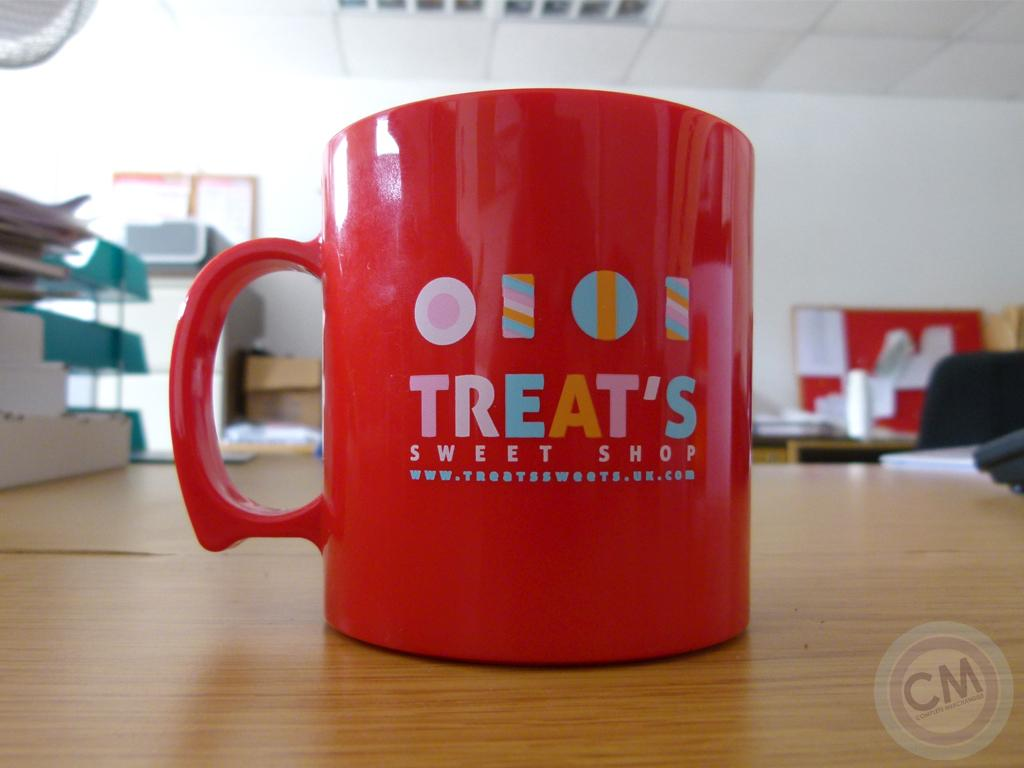<image>
Provide a brief description of the given image. An orange coffee mug has the store name Treat's Sweet Shop on it in multi-colored letters. 